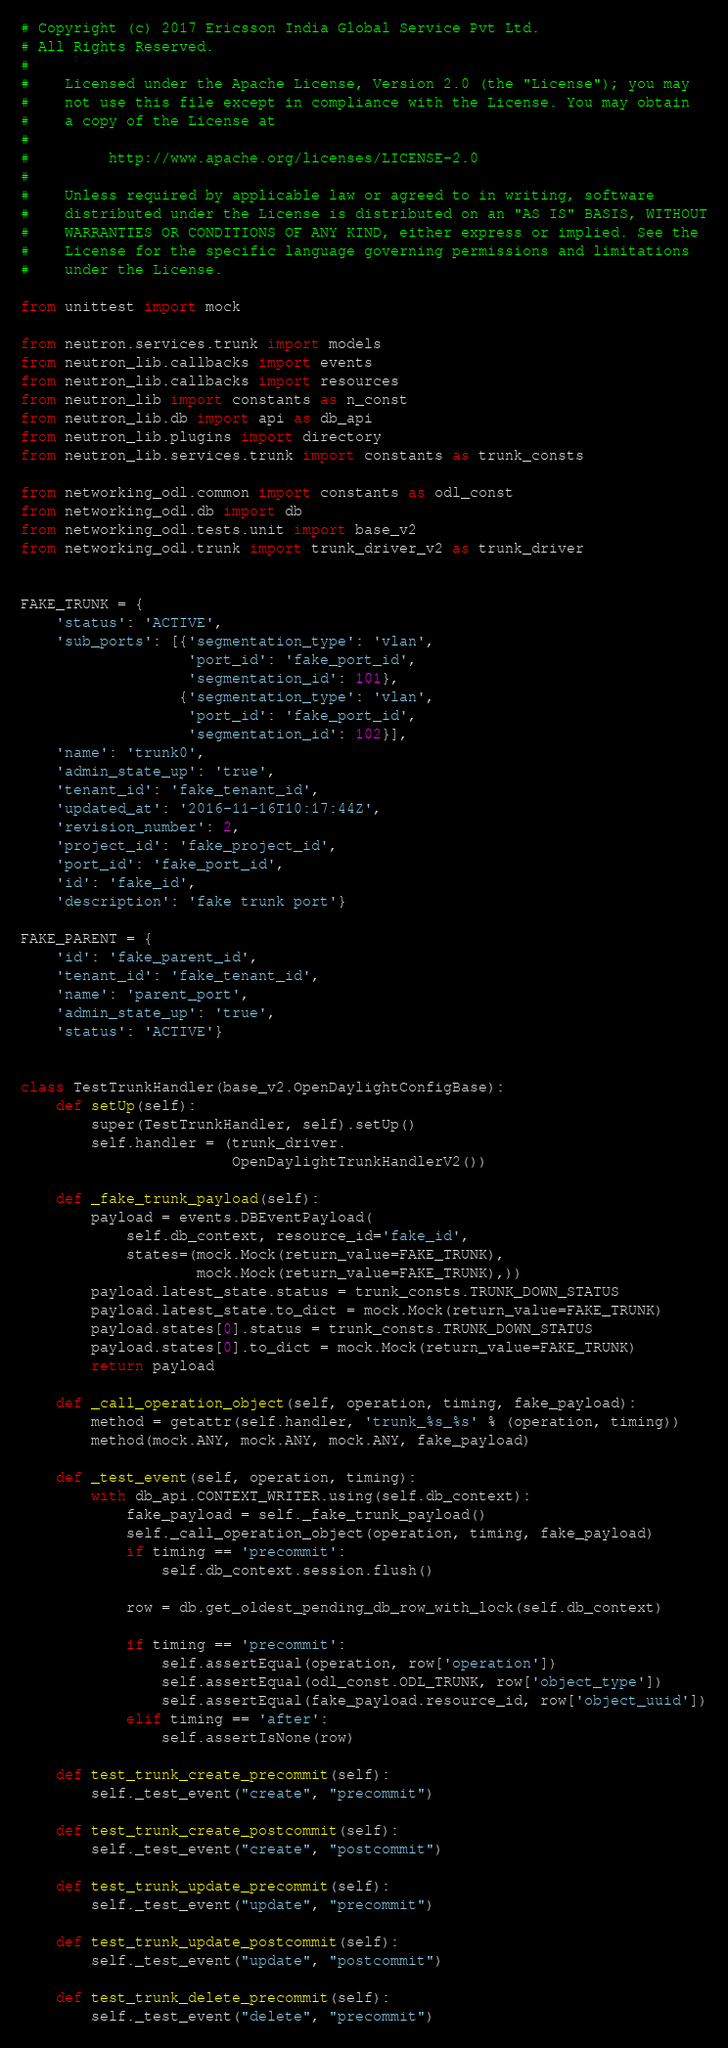Convert code to text. <code><loc_0><loc_0><loc_500><loc_500><_Python_># Copyright (c) 2017 Ericsson India Global Service Pvt Ltd.
# All Rights Reserved.
#
#    Licensed under the Apache License, Version 2.0 (the "License"); you may
#    not use this file except in compliance with the License. You may obtain
#    a copy of the License at
#
#         http://www.apache.org/licenses/LICENSE-2.0
#
#    Unless required by applicable law or agreed to in writing, software
#    distributed under the License is distributed on an "AS IS" BASIS, WITHOUT
#    WARRANTIES OR CONDITIONS OF ANY KIND, either express or implied. See the
#    License for the specific language governing permissions and limitations
#    under the License.

from unittest import mock

from neutron.services.trunk import models
from neutron_lib.callbacks import events
from neutron_lib.callbacks import resources
from neutron_lib import constants as n_const
from neutron_lib.db import api as db_api
from neutron_lib.plugins import directory
from neutron_lib.services.trunk import constants as trunk_consts

from networking_odl.common import constants as odl_const
from networking_odl.db import db
from networking_odl.tests.unit import base_v2
from networking_odl.trunk import trunk_driver_v2 as trunk_driver


FAKE_TRUNK = {
    'status': 'ACTIVE',
    'sub_ports': [{'segmentation_type': 'vlan',
                   'port_id': 'fake_port_id',
                   'segmentation_id': 101},
                  {'segmentation_type': 'vlan',
                   'port_id': 'fake_port_id',
                   'segmentation_id': 102}],
    'name': 'trunk0',
    'admin_state_up': 'true',
    'tenant_id': 'fake_tenant_id',
    'updated_at': '2016-11-16T10:17:44Z',
    'revision_number': 2,
    'project_id': 'fake_project_id',
    'port_id': 'fake_port_id',
    'id': 'fake_id',
    'description': 'fake trunk port'}

FAKE_PARENT = {
    'id': 'fake_parent_id',
    'tenant_id': 'fake_tenant_id',
    'name': 'parent_port',
    'admin_state_up': 'true',
    'status': 'ACTIVE'}


class TestTrunkHandler(base_v2.OpenDaylightConfigBase):
    def setUp(self):
        super(TestTrunkHandler, self).setUp()
        self.handler = (trunk_driver.
                        OpenDaylightTrunkHandlerV2())

    def _fake_trunk_payload(self):
        payload = events.DBEventPayload(
            self.db_context, resource_id='fake_id',
            states=(mock.Mock(return_value=FAKE_TRUNK),
                    mock.Mock(return_value=FAKE_TRUNK),))
        payload.latest_state.status = trunk_consts.TRUNK_DOWN_STATUS
        payload.latest_state.to_dict = mock.Mock(return_value=FAKE_TRUNK)
        payload.states[0].status = trunk_consts.TRUNK_DOWN_STATUS
        payload.states[0].to_dict = mock.Mock(return_value=FAKE_TRUNK)
        return payload

    def _call_operation_object(self, operation, timing, fake_payload):
        method = getattr(self.handler, 'trunk_%s_%s' % (operation, timing))
        method(mock.ANY, mock.ANY, mock.ANY, fake_payload)

    def _test_event(self, operation, timing):
        with db_api.CONTEXT_WRITER.using(self.db_context):
            fake_payload = self._fake_trunk_payload()
            self._call_operation_object(operation, timing, fake_payload)
            if timing == 'precommit':
                self.db_context.session.flush()

            row = db.get_oldest_pending_db_row_with_lock(self.db_context)

            if timing == 'precommit':
                self.assertEqual(operation, row['operation'])
                self.assertEqual(odl_const.ODL_TRUNK, row['object_type'])
                self.assertEqual(fake_payload.resource_id, row['object_uuid'])
            elif timing == 'after':
                self.assertIsNone(row)

    def test_trunk_create_precommit(self):
        self._test_event("create", "precommit")

    def test_trunk_create_postcommit(self):
        self._test_event("create", "postcommit")

    def test_trunk_update_precommit(self):
        self._test_event("update", "precommit")

    def test_trunk_update_postcommit(self):
        self._test_event("update", "postcommit")

    def test_trunk_delete_precommit(self):
        self._test_event("delete", "precommit")
</code> 